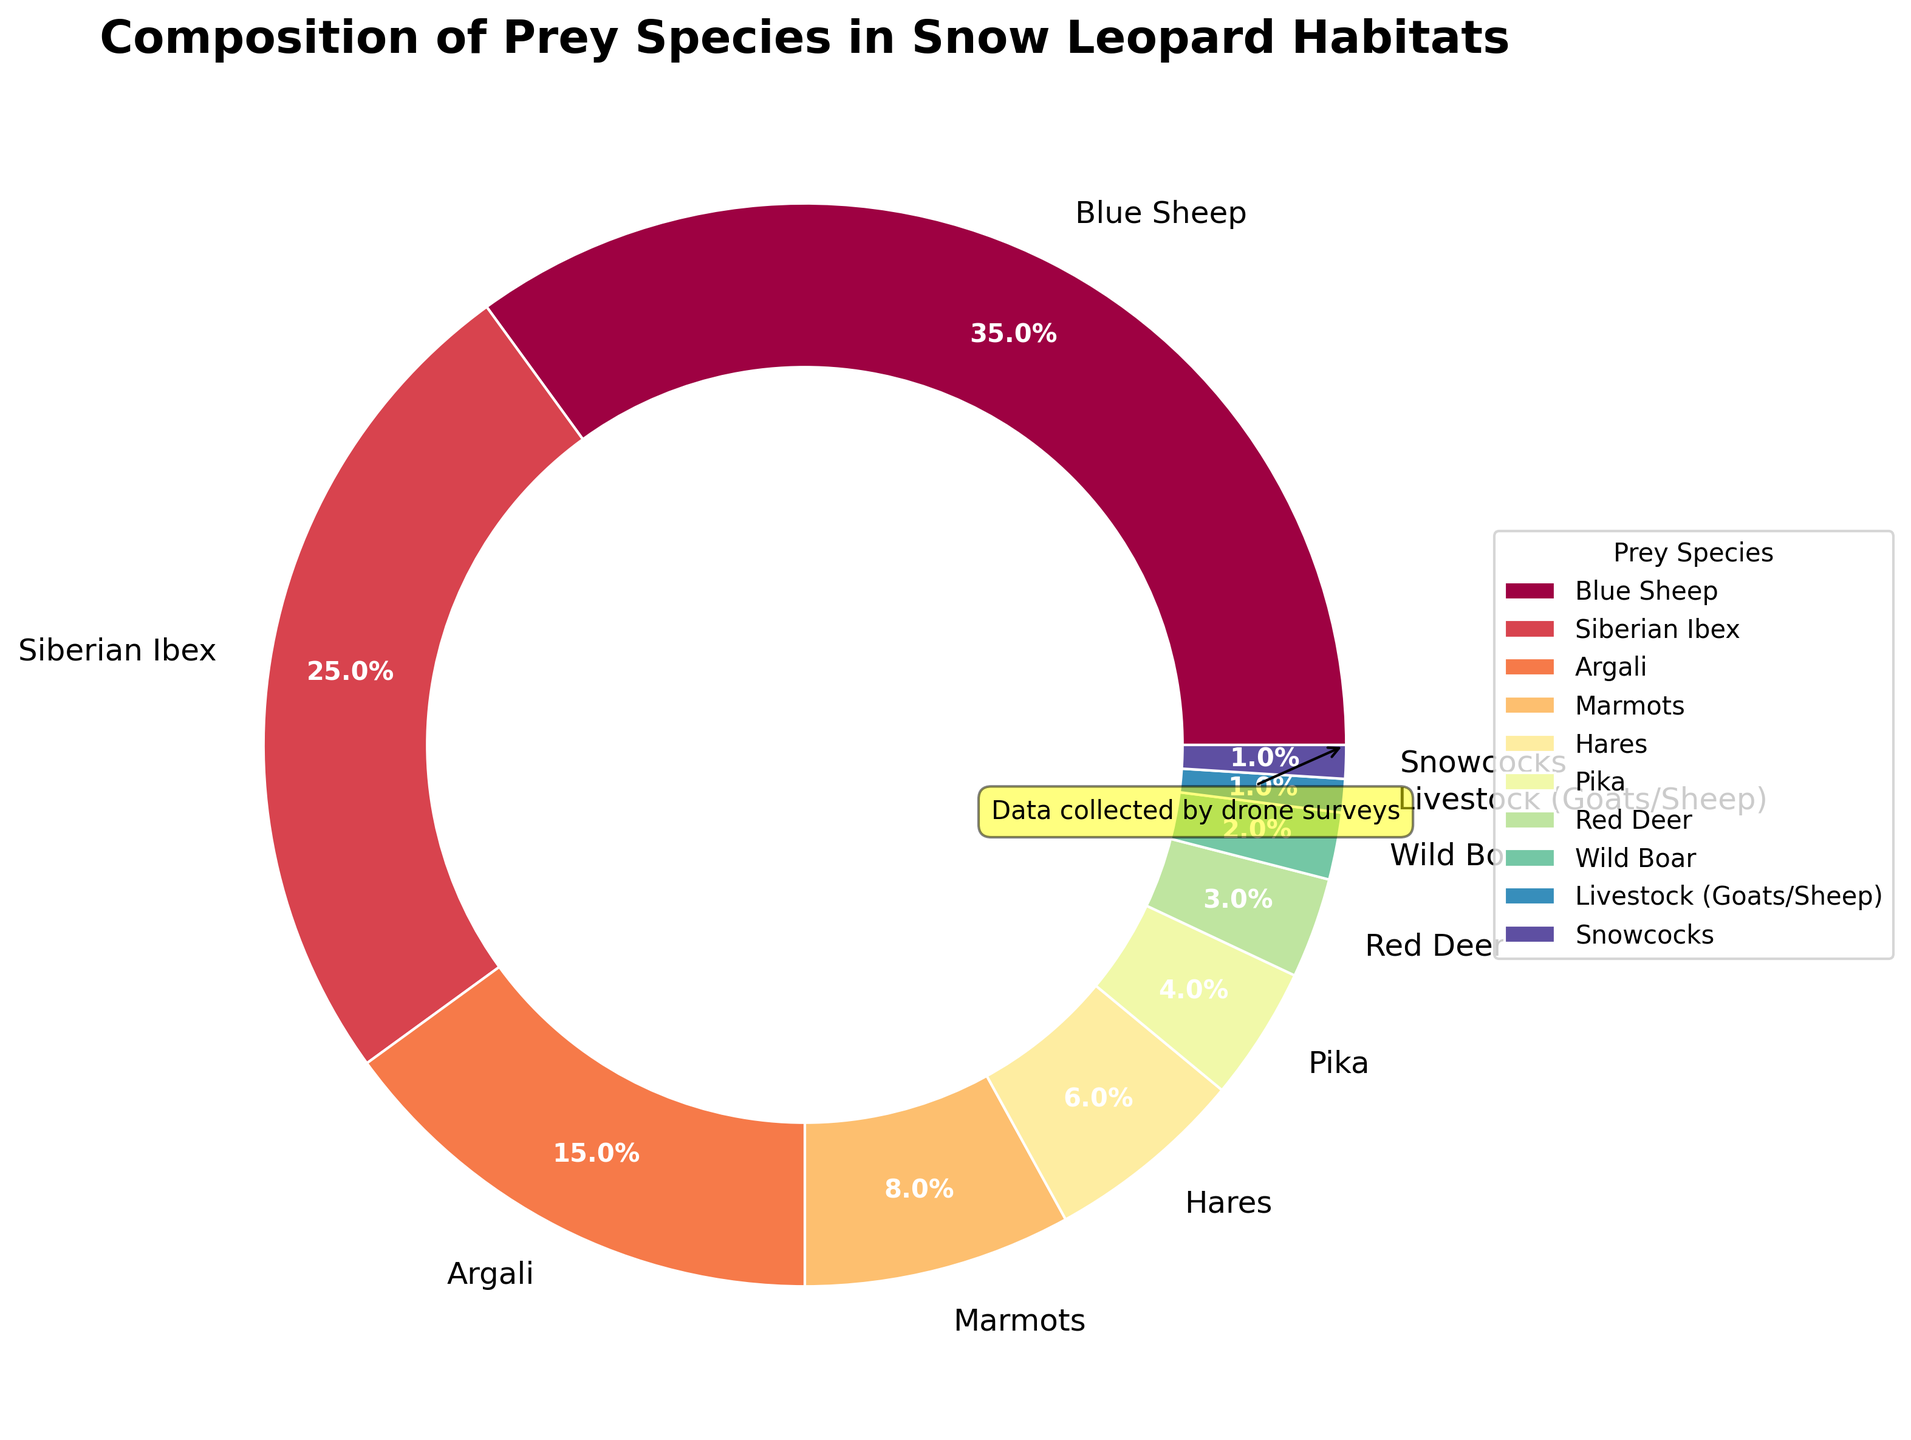What is the most observed prey species in the snow leopard habitats? By looking at the pie chart, the largest wedge represents Blue Sheep. Thus, we can infer that Blue Sheep is the most observed prey species.
Answer: Blue Sheep What percentage of the prey species is made up of Marmots and Hares combined? Marmots contribute 8% and Hares contribute 6%. Adding these percentages together gives 8% + 6% = 14%.
Answer: 14% Which species is represented by the smallest wedge, and what is its percentage? The smallest wedge in the pie chart represents Livestock (Goats/Sheep) and Snowcocks. Both are 1%.
Answer: Livestock (Goats/Sheep) and Snowcocks, 1% How much greater is the percentage of Blue Sheep compared to Siberian Ibex? Blue Sheep is 35%, and Siberian Ibex is 25%. Subtracting Ibex's percentage from Blue Sheep's gives 35% - 25% = 10%.
Answer: 10% What is the combined percentage of all prey species observed that contribute less than 10% each? The species that contribute less than 10% each are Marmots (8%), Hares (6%), Pika (4%), Red Deer (3%), Wild Boar (2%), Livestock (Goats/Sheep) (1%), and Snowcocks (1%). Adding these percentages together gives 8% + 6% + 4% + 3% + 2% + 1% + 1% = 25%.
Answer: 25% Which prey species collectively account for over half of the prey observed? Blue Sheep is 35% and adding the next largest, Siberian Ibex at 25%, gives 35% + 25% = 60%, which exceeds half (50%). Thus, Blue Sheep and Siberian Ibex collectively account for over half.
Answer: Blue Sheep and Siberian Ibex What is the total percentage of prey species represented by Argali, Pika, and Red Deer? Argali is 15%, Pika is 4%, and Red Deer is 3%. Adding these percentages gives 15% + 4% + 3% = 22%.
Answer: 22% Which visual element denotes the largest percentage of prey observed, and what is its significance? The largest wedge in the pie chart, representing Blue Sheep at 35%, denotes the largest percentage of prey observed. The size of the wedge shows that Blue Sheep is the most prevalent prey species for snow leopards.
Answer: Largest wedge, Blue Sheep, 35% 